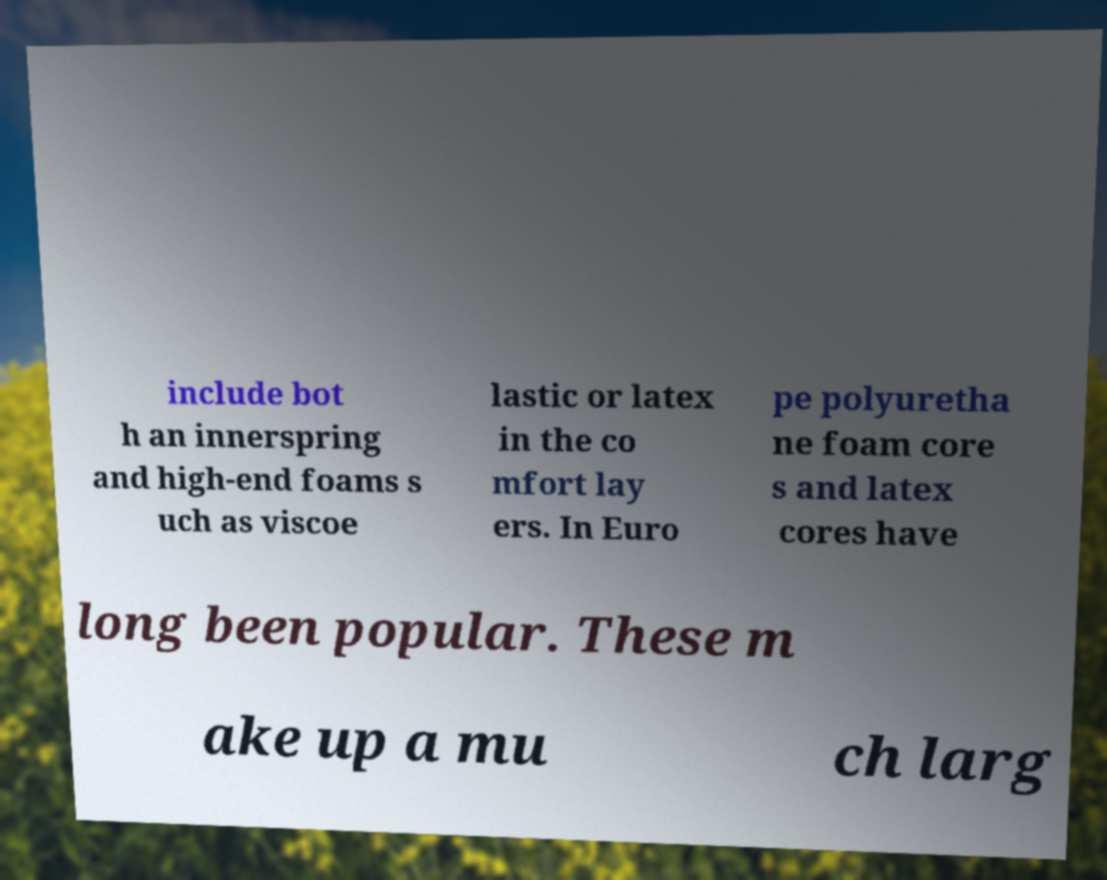Please read and relay the text visible in this image. What does it say? include bot h an innerspring and high-end foams s uch as viscoe lastic or latex in the co mfort lay ers. In Euro pe polyuretha ne foam core s and latex cores have long been popular. These m ake up a mu ch larg 